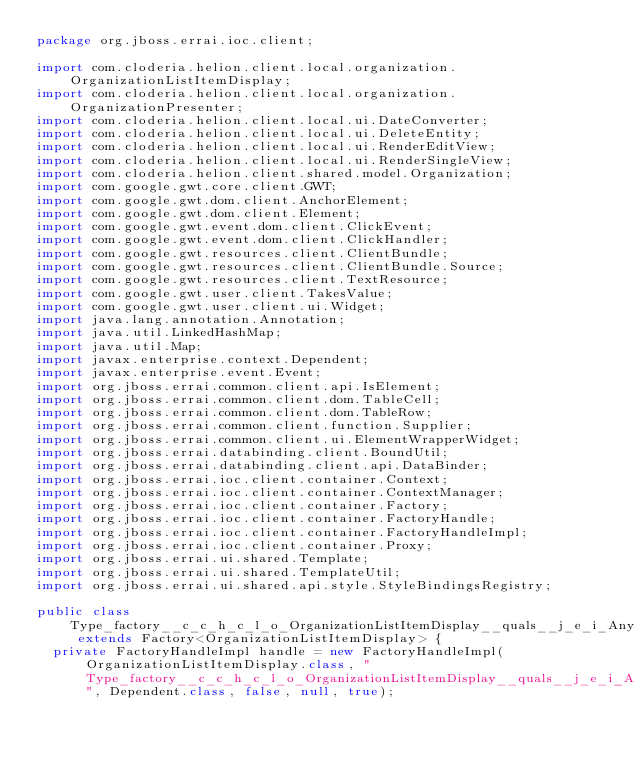<code> <loc_0><loc_0><loc_500><loc_500><_Java_>package org.jboss.errai.ioc.client;

import com.cloderia.helion.client.local.organization.OrganizationListItemDisplay;
import com.cloderia.helion.client.local.organization.OrganizationPresenter;
import com.cloderia.helion.client.local.ui.DateConverter;
import com.cloderia.helion.client.local.ui.DeleteEntity;
import com.cloderia.helion.client.local.ui.RenderEditView;
import com.cloderia.helion.client.local.ui.RenderSingleView;
import com.cloderia.helion.client.shared.model.Organization;
import com.google.gwt.core.client.GWT;
import com.google.gwt.dom.client.AnchorElement;
import com.google.gwt.dom.client.Element;
import com.google.gwt.event.dom.client.ClickEvent;
import com.google.gwt.event.dom.client.ClickHandler;
import com.google.gwt.resources.client.ClientBundle;
import com.google.gwt.resources.client.ClientBundle.Source;
import com.google.gwt.resources.client.TextResource;
import com.google.gwt.user.client.TakesValue;
import com.google.gwt.user.client.ui.Widget;
import java.lang.annotation.Annotation;
import java.util.LinkedHashMap;
import java.util.Map;
import javax.enterprise.context.Dependent;
import javax.enterprise.event.Event;
import org.jboss.errai.common.client.api.IsElement;
import org.jboss.errai.common.client.dom.TableCell;
import org.jboss.errai.common.client.dom.TableRow;
import org.jboss.errai.common.client.function.Supplier;
import org.jboss.errai.common.client.ui.ElementWrapperWidget;
import org.jboss.errai.databinding.client.BoundUtil;
import org.jboss.errai.databinding.client.api.DataBinder;
import org.jboss.errai.ioc.client.container.Context;
import org.jboss.errai.ioc.client.container.ContextManager;
import org.jboss.errai.ioc.client.container.Factory;
import org.jboss.errai.ioc.client.container.FactoryHandle;
import org.jboss.errai.ioc.client.container.FactoryHandleImpl;
import org.jboss.errai.ioc.client.container.Proxy;
import org.jboss.errai.ui.shared.Template;
import org.jboss.errai.ui.shared.TemplateUtil;
import org.jboss.errai.ui.shared.api.style.StyleBindingsRegistry;

public class Type_factory__c_c_h_c_l_o_OrganizationListItemDisplay__quals__j_e_i_Any_j_e_i_Default extends Factory<OrganizationListItemDisplay> {
  private FactoryHandleImpl handle = new FactoryHandleImpl(OrganizationListItemDisplay.class, "Type_factory__c_c_h_c_l_o_OrganizationListItemDisplay__quals__j_e_i_Any_j_e_i_Default", Dependent.class, false, null, true);</code> 